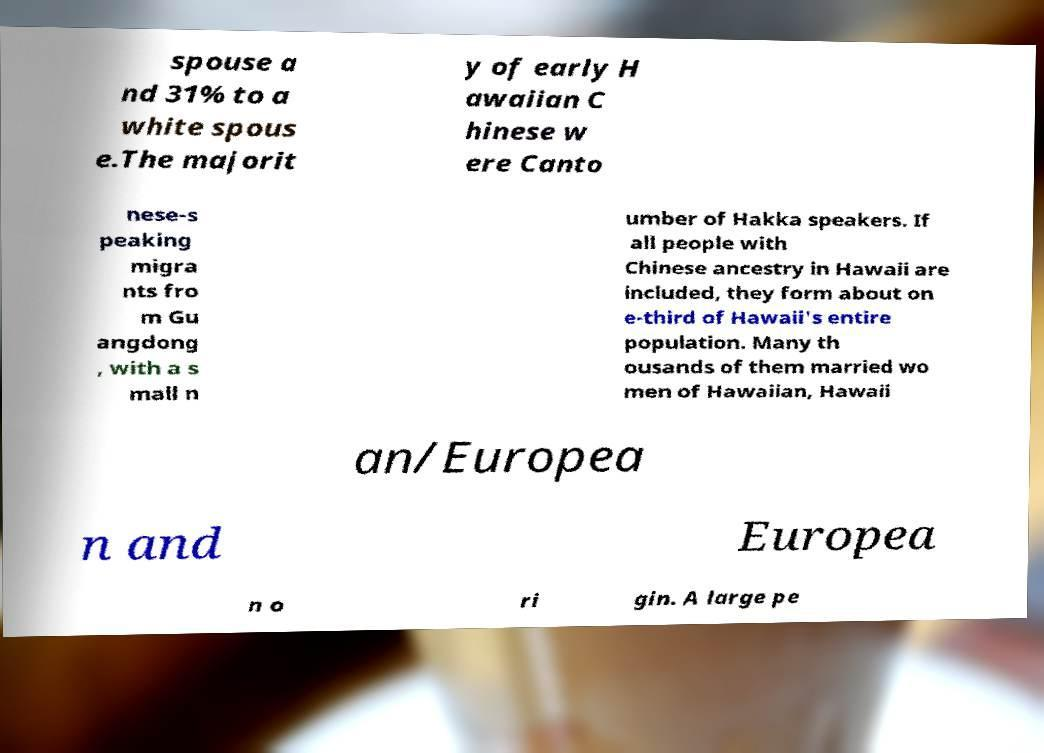Could you extract and type out the text from this image? spouse a nd 31% to a white spous e.The majorit y of early H awaiian C hinese w ere Canto nese-s peaking migra nts fro m Gu angdong , with a s mall n umber of Hakka speakers. If all people with Chinese ancestry in Hawaii are included, they form about on e-third of Hawaii's entire population. Many th ousands of them married wo men of Hawaiian, Hawaii an/Europea n and Europea n o ri gin. A large pe 